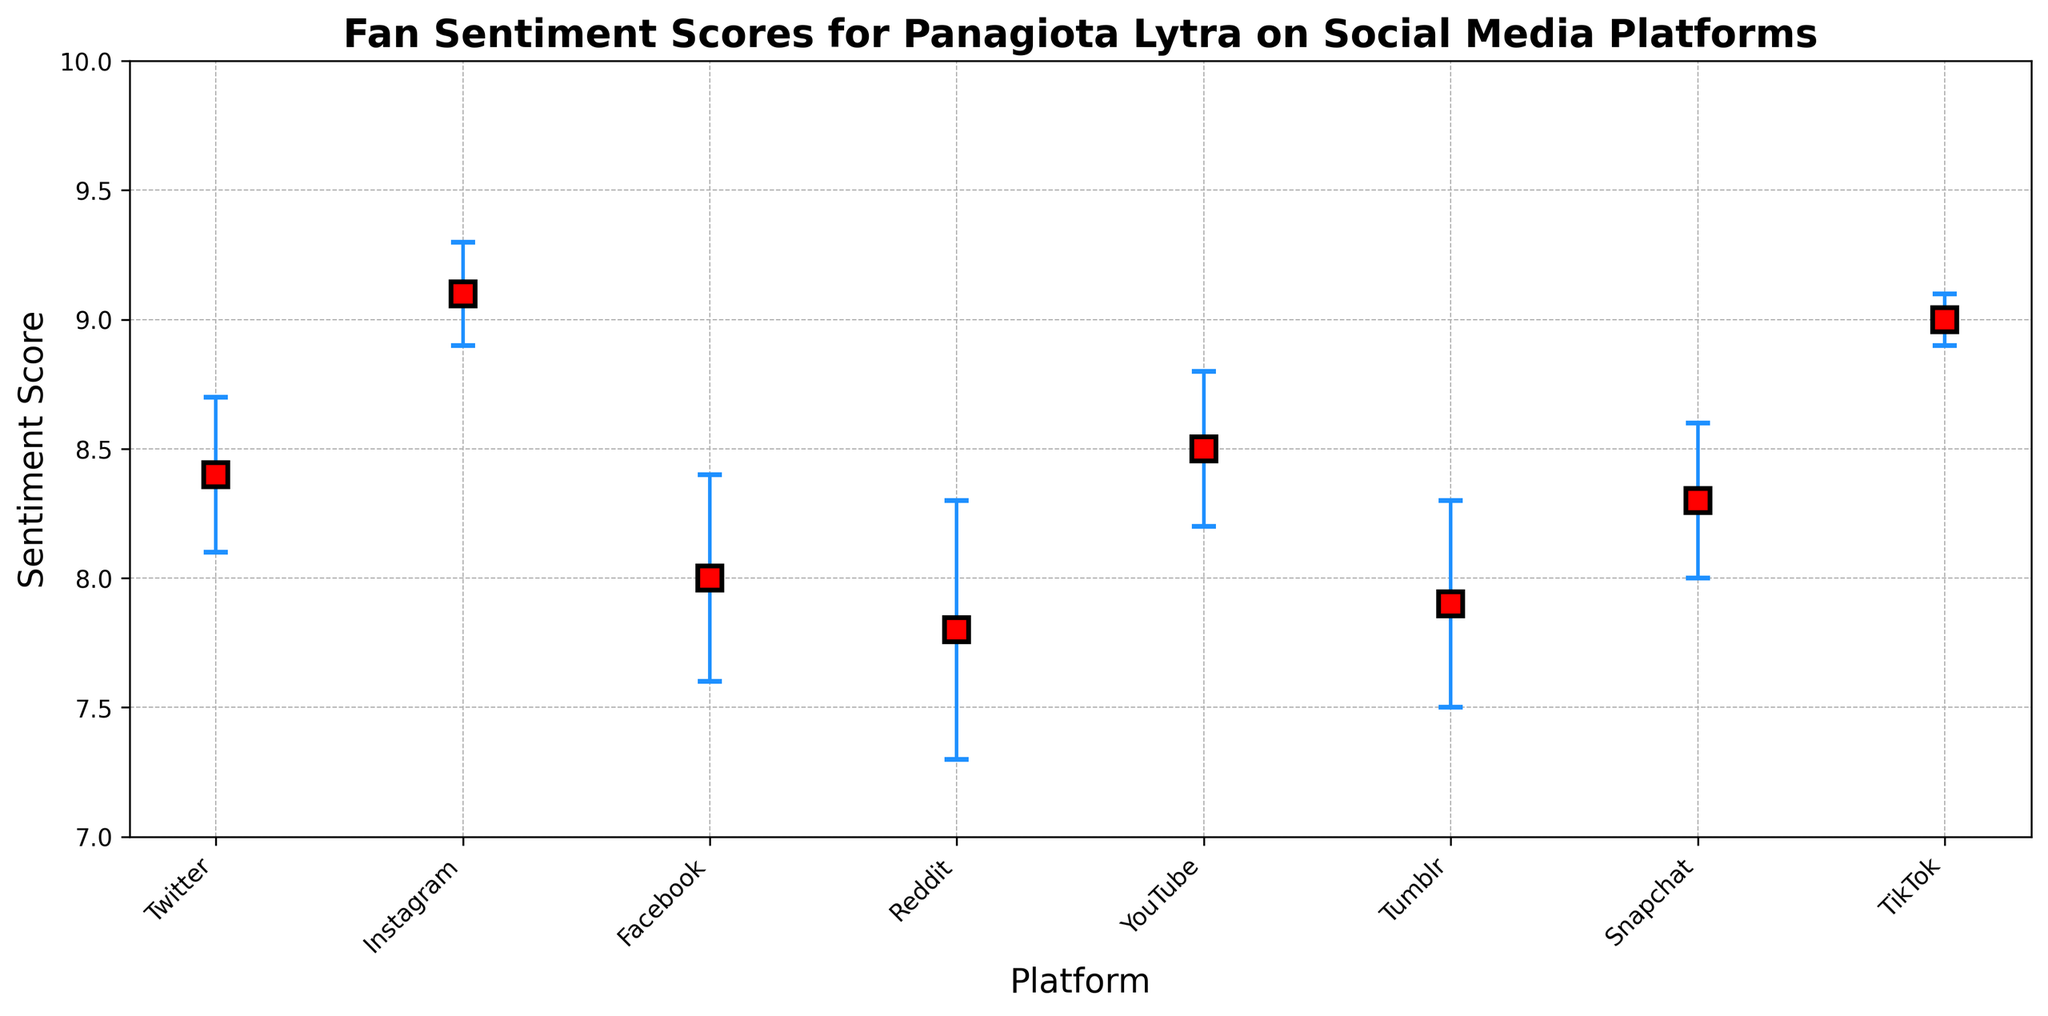What platform has the highest sentiment score? The highest sentiment score occurs on the platform with the tallest marker on the y-axis. In this case, it is Instagram with a score of 9.1.
Answer: Instagram Which platform has the lowest sentiment score? The lowest sentiment score is found by identifying the shortest marker on the y-axis. Reddit has the lowest score of 7.8.
Answer: Reddit What is the average sentiment score across all platforms? Sum all of the sentiment scores (8.4 + 9.1 + 8.0 + 7.8 + 8.5 + 7.9 + 8.3 + 9.0) and divide by the number of platforms (8). The sum is 66.0, so the average is 66.0 / 8 = 8.25.
Answer: 8.25 Which platform has the largest standard deviation in sentiment score? The largest standard deviation is found by the longest error bar on the y-axis. Reddit has the largest standard deviation of 0.5.
Answer: Reddit Do any platforms have the same sentiment score? Check if any platforms have markers at the same height. None of the sentiment scores for the platforms are identical.
Answer: No What's the difference in sentiment score between Instagram and Facebook? Subtract the sentiment score of Facebook (8.0) from Instagram (9.1). 9.1 - 8.0 = 1.1
Answer: 1.1 Which platform has the smallest standard deviation in sentiment score? The smallest standard deviation is identified by finding the shortest error bar. TikTok has the smallest standard deviation of 0.1.
Answer: TikTok Is the sentiment score on Twitter greater than or less than on YouTube? Compare the height of the markers for Twitter (8.4) and YouTube (8.5). Twitter's sentiment score is less than YouTube's.
Answer: Less than Are the sentiment scores on Snapchat and Twitter equal? Compare the values of the sentiment scores for Snapchat (8.3) and Twitter (8.4). They are not equal.
Answer: No What is the range of sentiment scores across all platforms? Identify the maximum (Instagram, 9.1) and minimum (Reddit, 7.8) scores, then compute the difference. 9.1 - 7.8 = 1.3
Answer: 1.3 